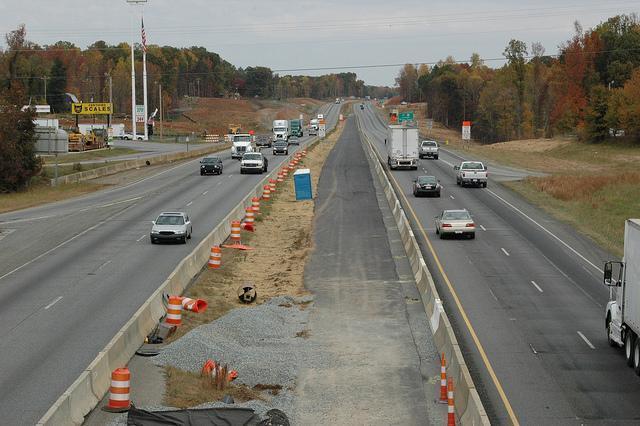How many switchbacks are in the picture?
Give a very brief answer. 0. 